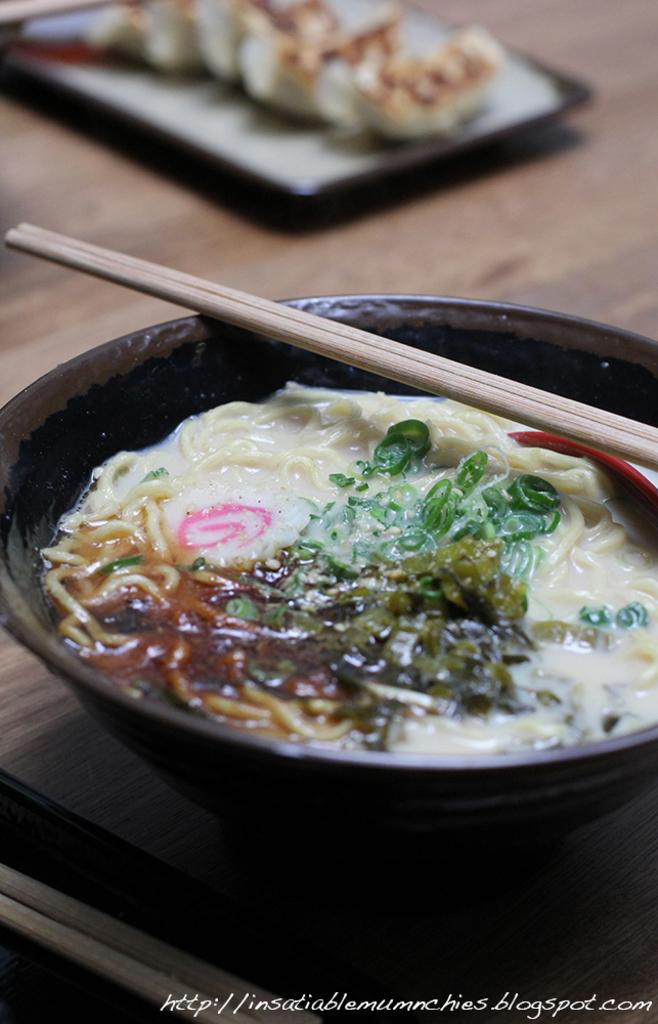What is on the plate that is visible in the image? There is food on a plate in the image. What utensil is present on the plate? Chopsticks are present on the plate. Where is the plate located in the image? The plate is on a table. What is the person teaching in the image? There is no person or teaching activity present in the image. How does the sponge contribute to the food on the plate? There is no sponge present in the image; it is a plate of food with chopsticks. 